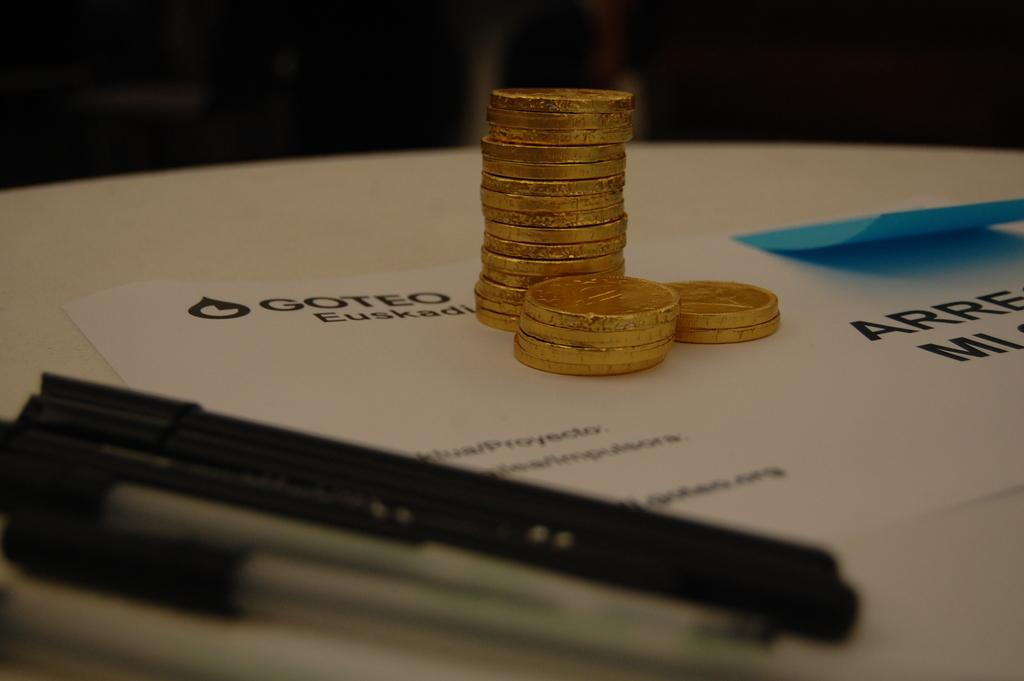<image>
Give a short and clear explanation of the subsequent image. Gold coins stacked on top of paper with the word GOTEO in black. 